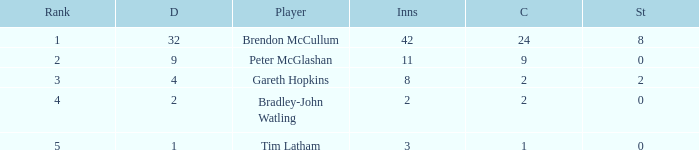List the ranks of all dismissals with a value of 4 3.0. 